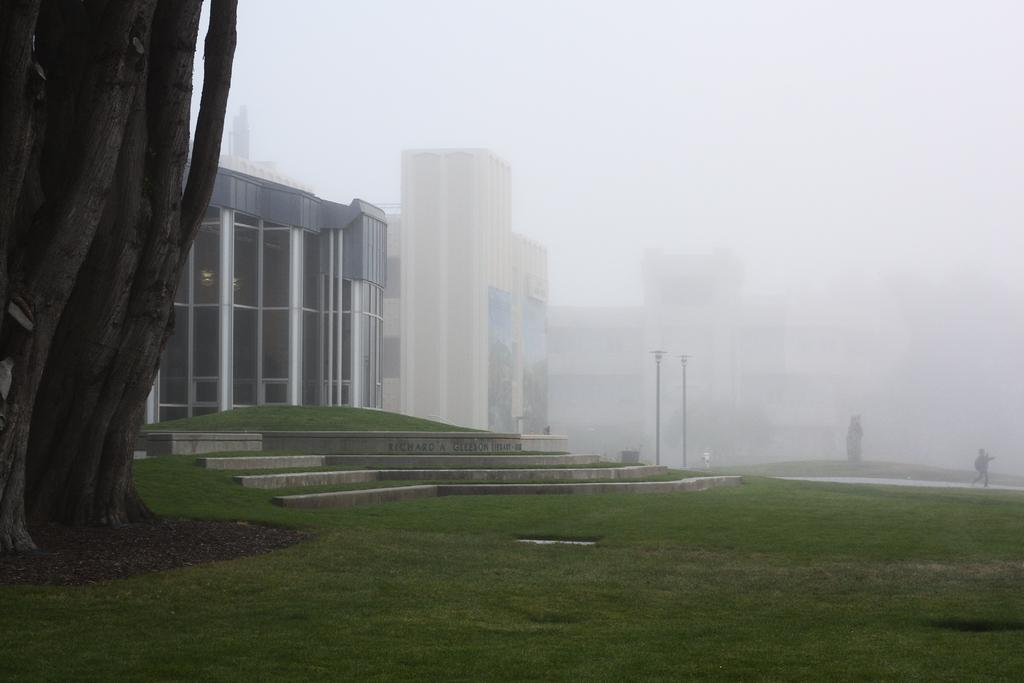What is the main structure visible in the picture? There is a building in the picture. How is the area around the building described? The area around the building is covered with dark fog. What type of vegetation is present in front of the building? There is grass in front of the building. Are there any other large objects or features in front of the building? Yes, there is a big tree in front of the building. Can you see any caves behind the big tree in the image? There is no mention of a cave in the image, and it is not visible behind the big tree. Is there a cat sitting on the grass in front of the building? There is no mention of a cat in the image, and it is not visible on the grass. 